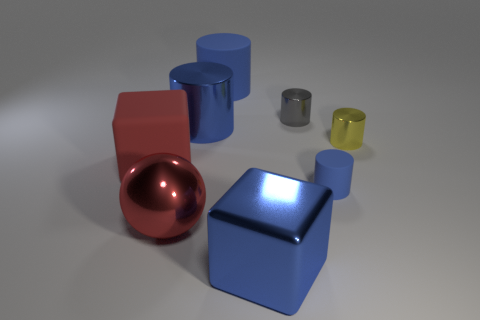Subtract all cyan spheres. How many blue cylinders are left? 3 Subtract 1 cylinders. How many cylinders are left? 4 Subtract all gray cylinders. Subtract all gray balls. How many cylinders are left? 4 Add 2 tiny blue shiny spheres. How many objects exist? 10 Subtract all cylinders. How many objects are left? 3 Add 7 rubber cylinders. How many rubber cylinders are left? 9 Add 7 red metallic things. How many red metallic things exist? 8 Subtract 1 red cubes. How many objects are left? 7 Subtract all tiny yellow cylinders. Subtract all big red cubes. How many objects are left? 6 